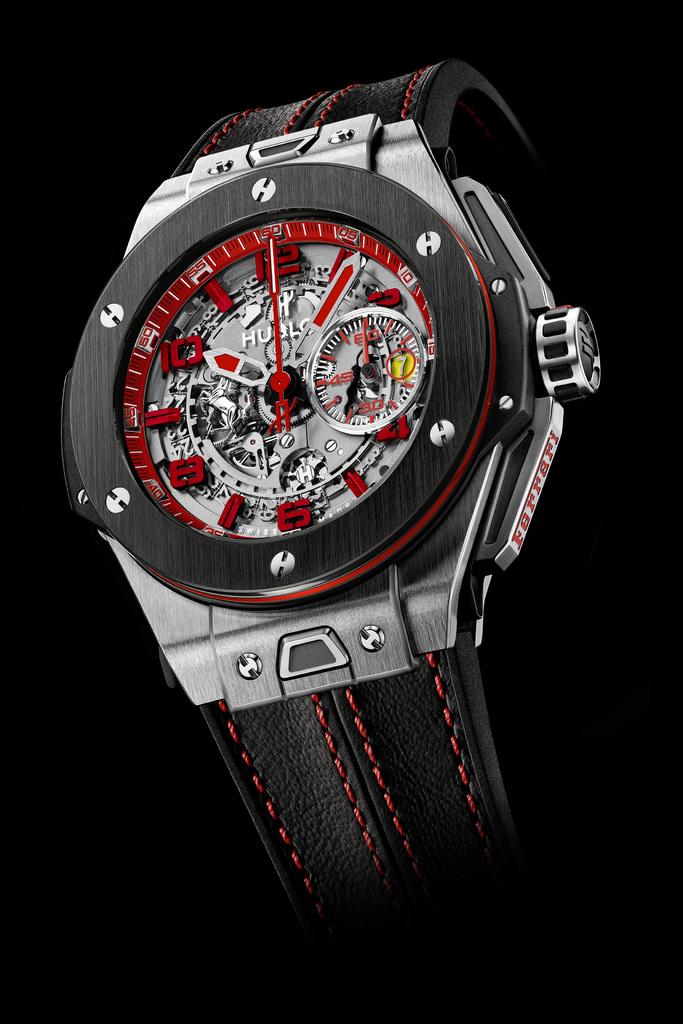What brand of watch is this?
Keep it short and to the point. Hublot. 